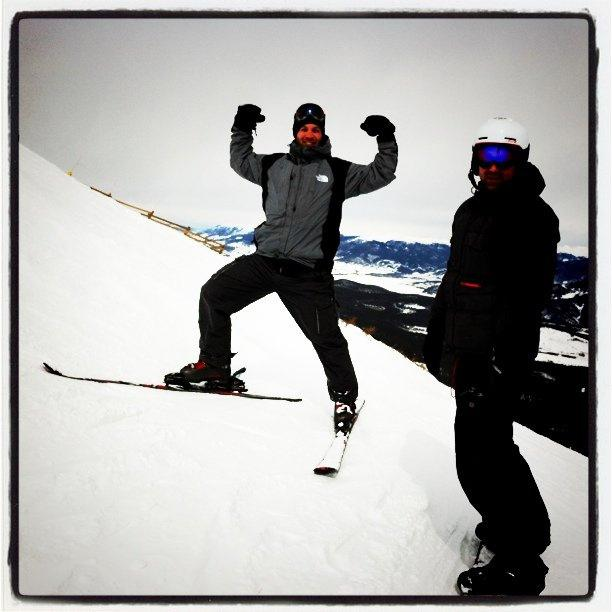What muscles in the male showing off?

Choices:
A) biceps
B) deltas
C) triceps
D) quads biceps 